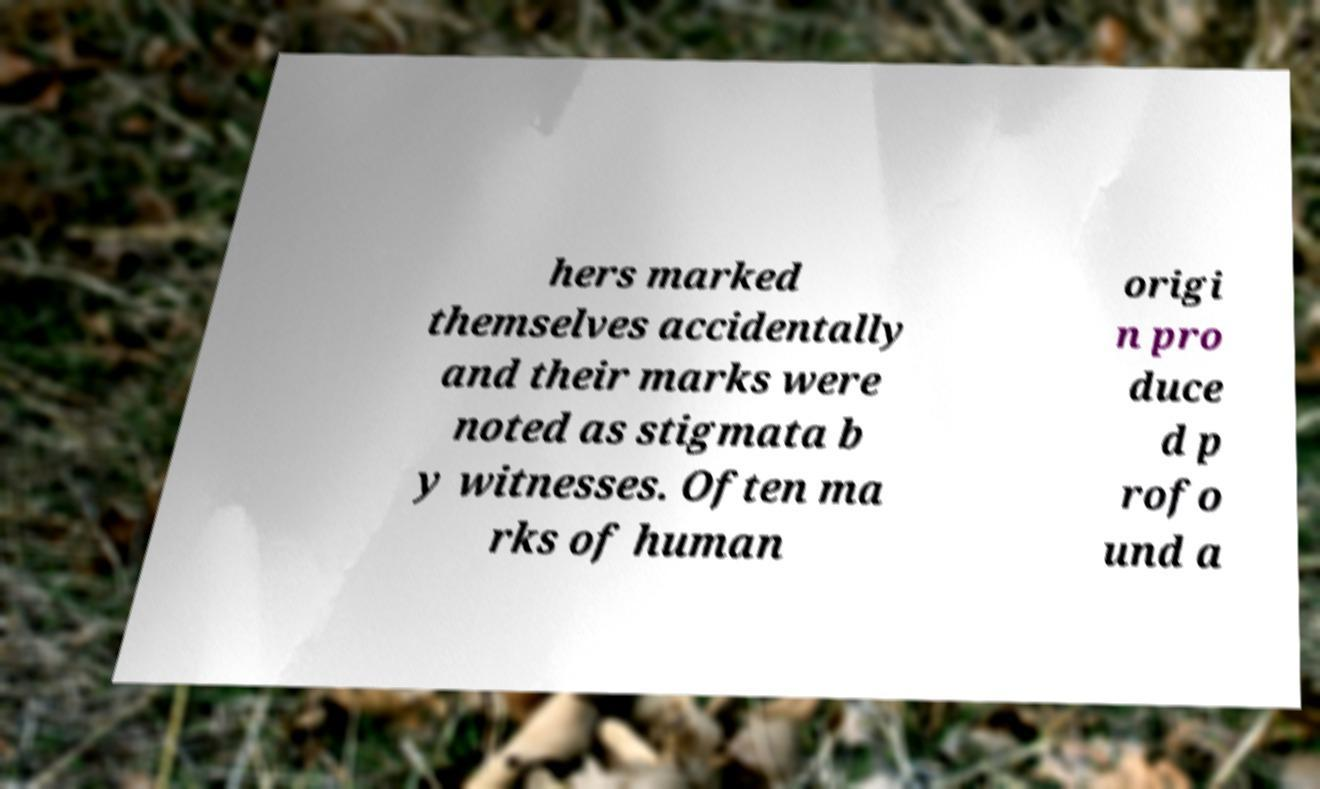For documentation purposes, I need the text within this image transcribed. Could you provide that? hers marked themselves accidentally and their marks were noted as stigmata b y witnesses. Often ma rks of human origi n pro duce d p rofo und a 